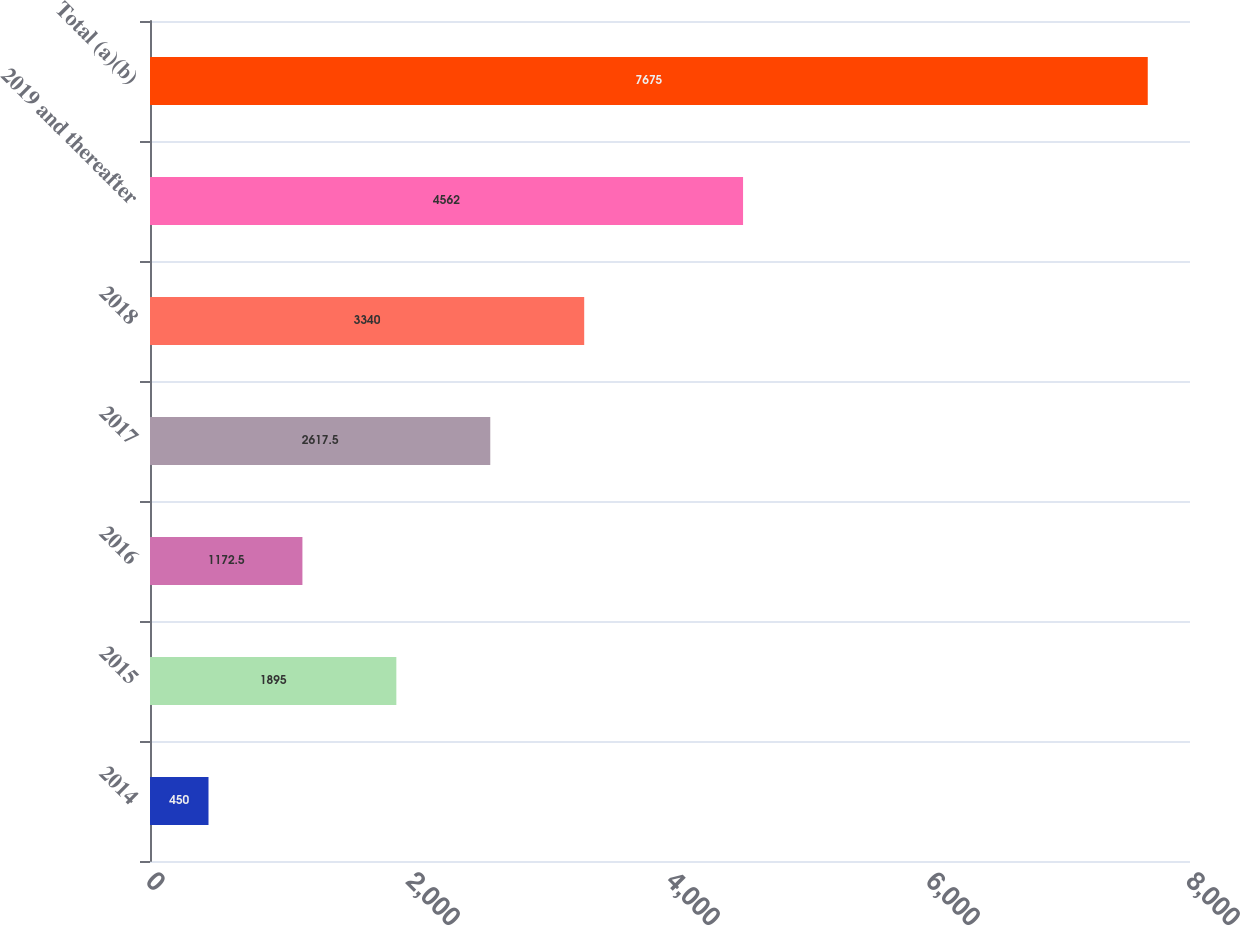Convert chart. <chart><loc_0><loc_0><loc_500><loc_500><bar_chart><fcel>2014<fcel>2015<fcel>2016<fcel>2017<fcel>2018<fcel>2019 and thereafter<fcel>Total (a)(b)<nl><fcel>450<fcel>1895<fcel>1172.5<fcel>2617.5<fcel>3340<fcel>4562<fcel>7675<nl></chart> 